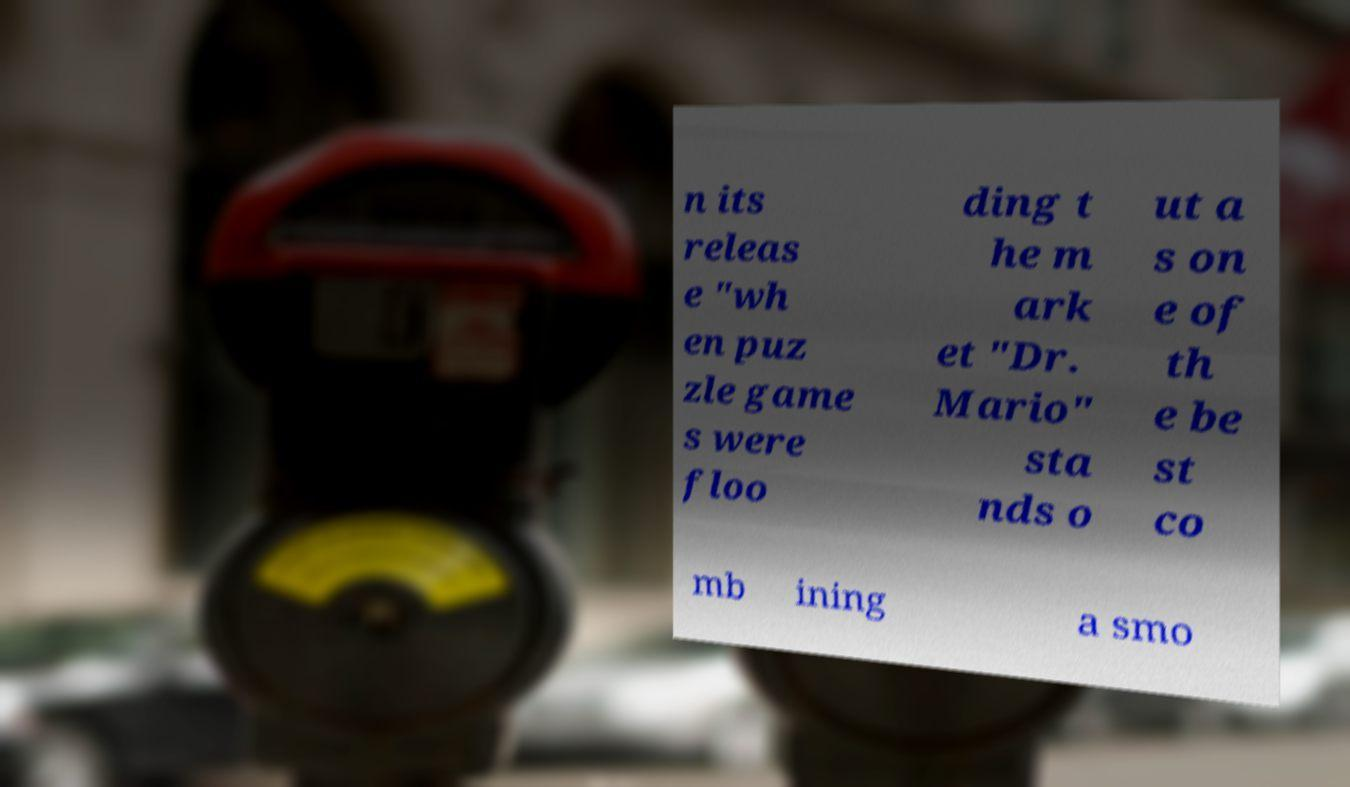I need the written content from this picture converted into text. Can you do that? n its releas e "wh en puz zle game s were floo ding t he m ark et "Dr. Mario" sta nds o ut a s on e of th e be st co mb ining a smo 